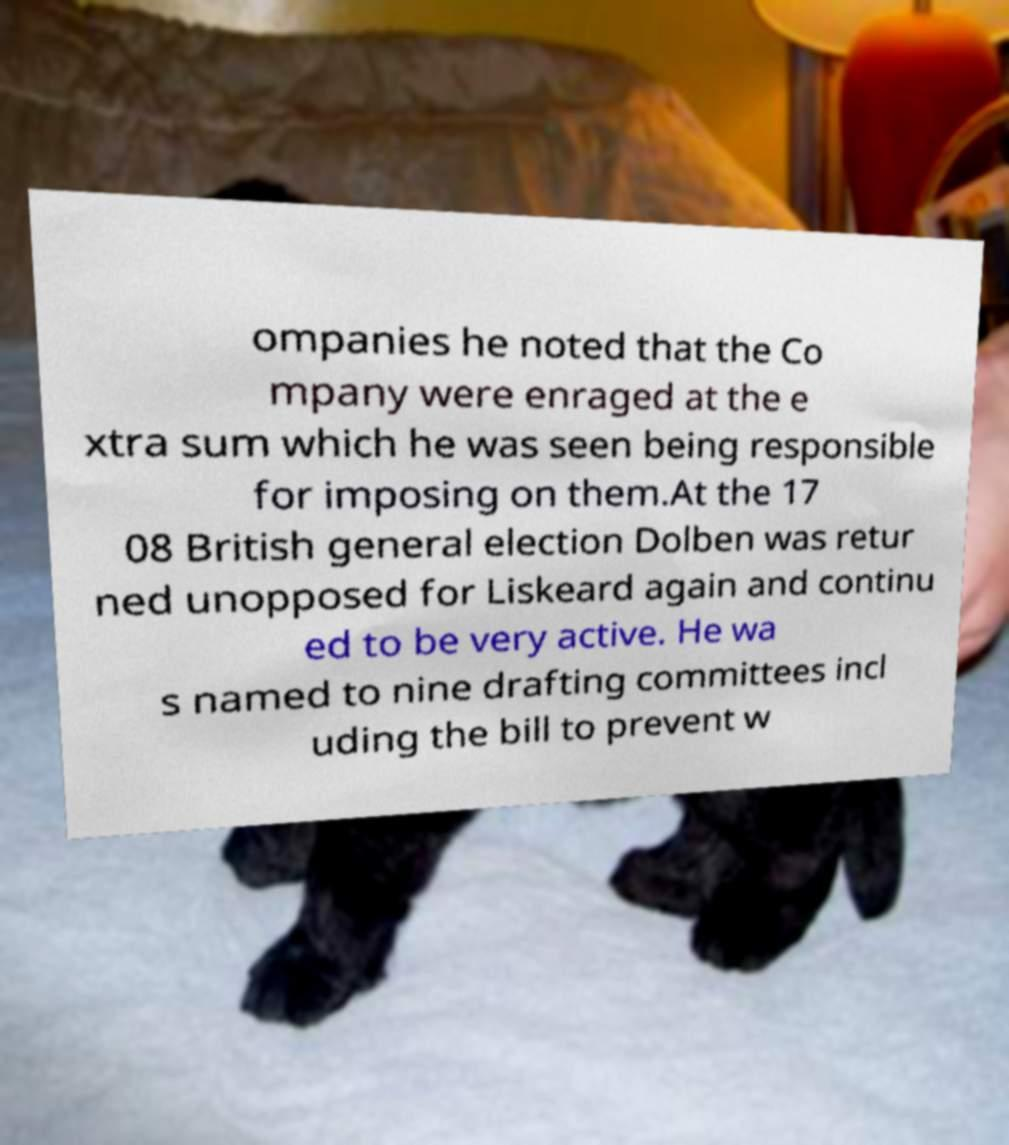Please identify and transcribe the text found in this image. ompanies he noted that the Co mpany were enraged at the e xtra sum which he was seen being responsible for imposing on them.At the 17 08 British general election Dolben was retur ned unopposed for Liskeard again and continu ed to be very active. He wa s named to nine drafting committees incl uding the bill to prevent w 